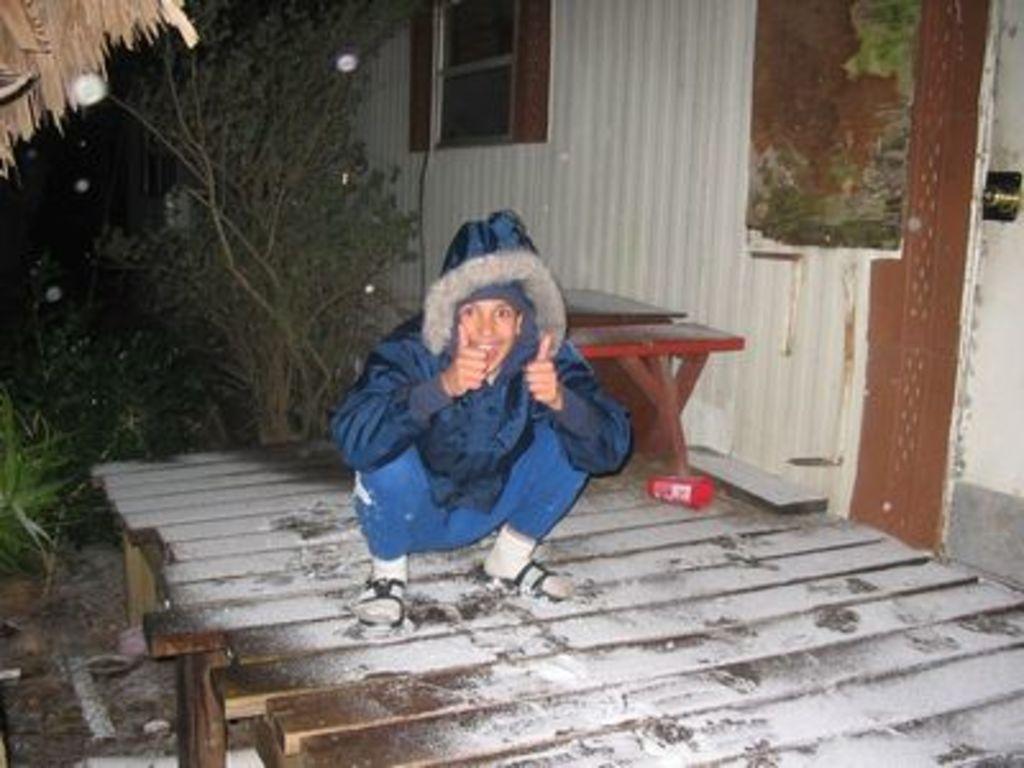Can you describe this image briefly? In this image we can see a person on the wooden platform, also we can see a table and a building, there are some plants, lights and trees. 